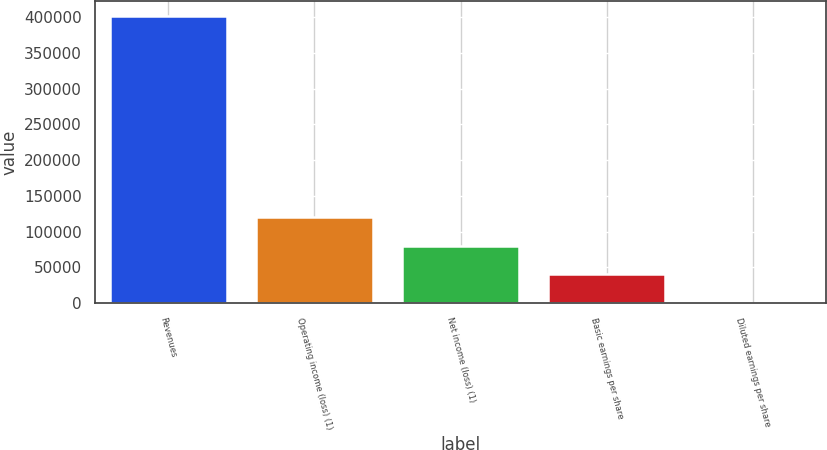<chart> <loc_0><loc_0><loc_500><loc_500><bar_chart><fcel>Revenues<fcel>Operating income (loss) (1)<fcel>Net income (loss) (1)<fcel>Basic earnings per share<fcel>Diluted earnings per share<nl><fcel>402041<fcel>120613<fcel>80408.6<fcel>40204.5<fcel>0.46<nl></chart> 